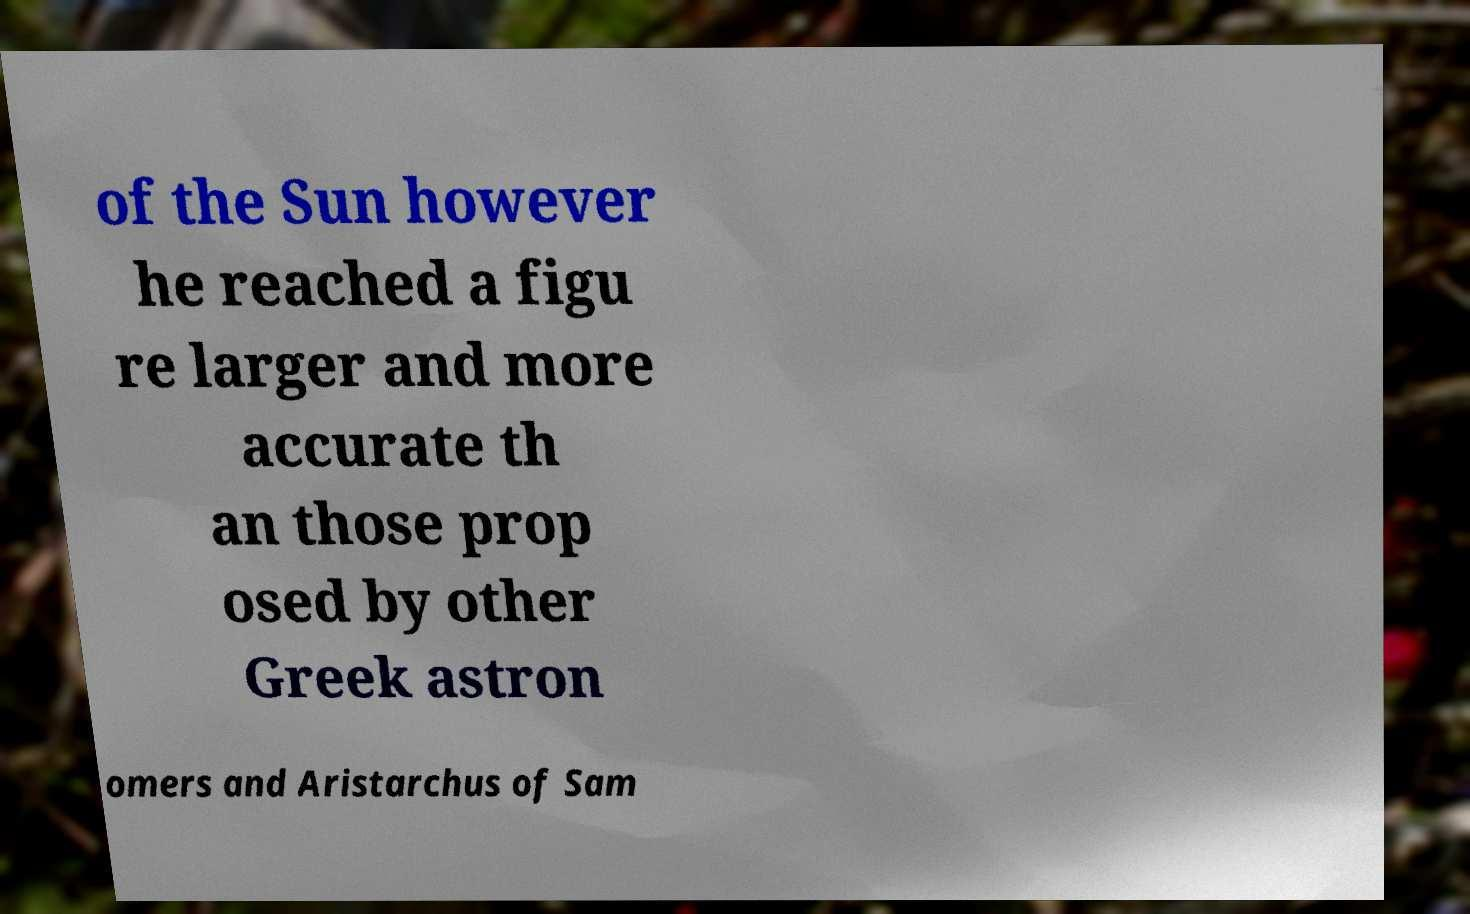Can you read and provide the text displayed in the image?This photo seems to have some interesting text. Can you extract and type it out for me? of the Sun however he reached a figu re larger and more accurate th an those prop osed by other Greek astron omers and Aristarchus of Sam 